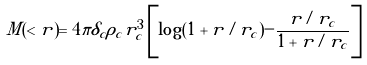Convert formula to latex. <formula><loc_0><loc_0><loc_500><loc_500>M ( < r ) = 4 \pi \delta _ { c } \rho _ { c } r _ { c } ^ { 3 } \left [ \log ( 1 + r / r _ { c } ) - \frac { r / r _ { c } } { 1 + r / r _ { c } } \right ]</formula> 